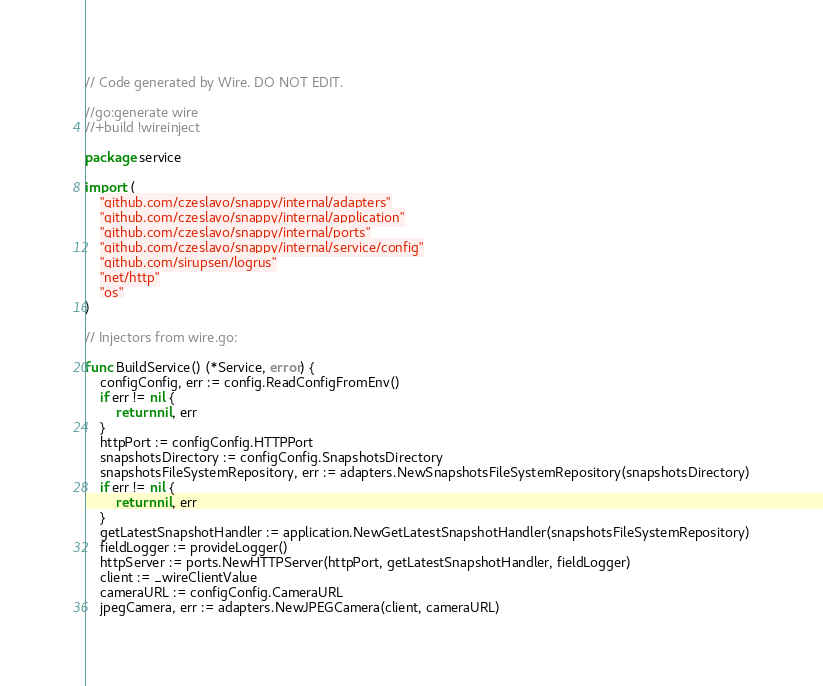<code> <loc_0><loc_0><loc_500><loc_500><_Go_>// Code generated by Wire. DO NOT EDIT.

//go:generate wire
//+build !wireinject

package service

import (
	"github.com/czeslavo/snappy/internal/adapters"
	"github.com/czeslavo/snappy/internal/application"
	"github.com/czeslavo/snappy/internal/ports"
	"github.com/czeslavo/snappy/internal/service/config"
	"github.com/sirupsen/logrus"
	"net/http"
	"os"
)

// Injectors from wire.go:

func BuildService() (*Service, error) {
	configConfig, err := config.ReadConfigFromEnv()
	if err != nil {
		return nil, err
	}
	httpPort := configConfig.HTTPPort
	snapshotsDirectory := configConfig.SnapshotsDirectory
	snapshotsFileSystemRepository, err := adapters.NewSnapshotsFileSystemRepository(snapshotsDirectory)
	if err != nil {
		return nil, err
	}
	getLatestSnapshotHandler := application.NewGetLatestSnapshotHandler(snapshotsFileSystemRepository)
	fieldLogger := provideLogger()
	httpServer := ports.NewHTTPServer(httpPort, getLatestSnapshotHandler, fieldLogger)
	client := _wireClientValue
	cameraURL := configConfig.CameraURL
	jpegCamera, err := adapters.NewJPEGCamera(client, cameraURL)</code> 